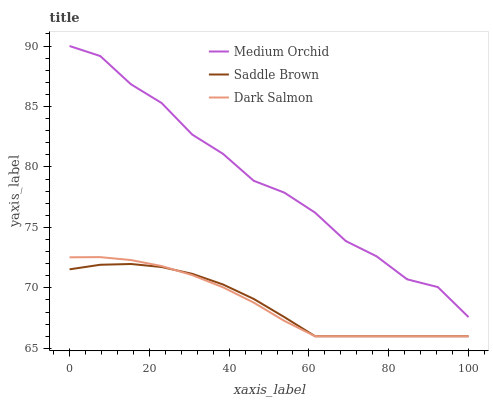Does Saddle Brown have the minimum area under the curve?
Answer yes or no. Yes. Does Medium Orchid have the maximum area under the curve?
Answer yes or no. Yes. Does Dark Salmon have the minimum area under the curve?
Answer yes or no. No. Does Dark Salmon have the maximum area under the curve?
Answer yes or no. No. Is Dark Salmon the smoothest?
Answer yes or no. Yes. Is Medium Orchid the roughest?
Answer yes or no. Yes. Is Saddle Brown the smoothest?
Answer yes or no. No. Is Saddle Brown the roughest?
Answer yes or no. No. Does Saddle Brown have the lowest value?
Answer yes or no. Yes. Does Medium Orchid have the highest value?
Answer yes or no. Yes. Does Dark Salmon have the highest value?
Answer yes or no. No. Is Saddle Brown less than Medium Orchid?
Answer yes or no. Yes. Is Medium Orchid greater than Saddle Brown?
Answer yes or no. Yes. Does Dark Salmon intersect Saddle Brown?
Answer yes or no. Yes. Is Dark Salmon less than Saddle Brown?
Answer yes or no. No. Is Dark Salmon greater than Saddle Brown?
Answer yes or no. No. Does Saddle Brown intersect Medium Orchid?
Answer yes or no. No. 